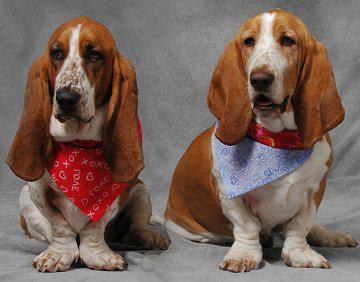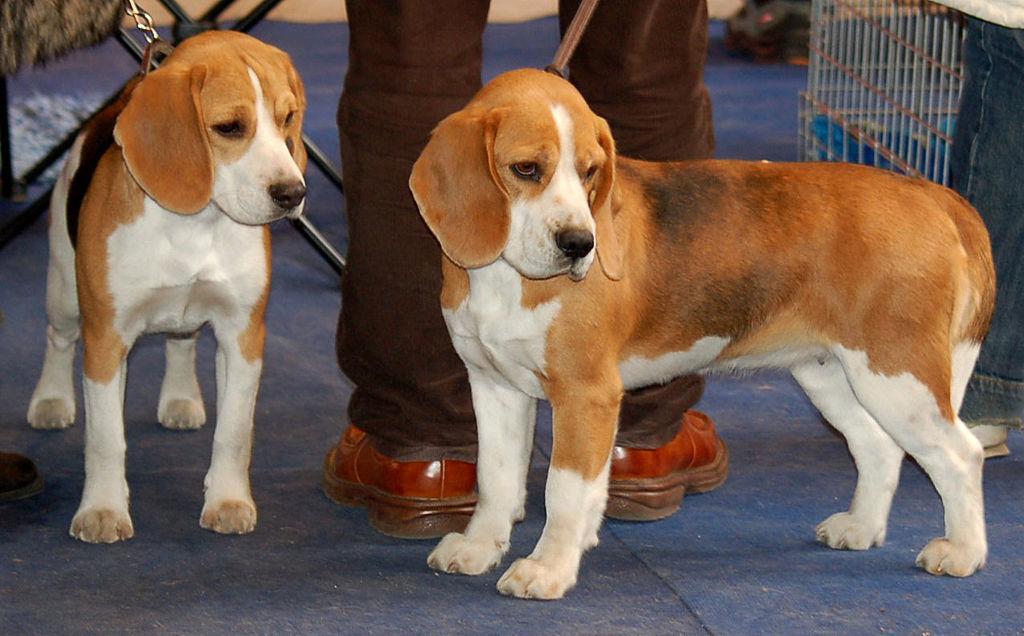The first image is the image on the left, the second image is the image on the right. Considering the images on both sides, is "There are more basset hounds in the right image than in the left." valid? Answer yes or no. No. The first image is the image on the left, the second image is the image on the right. For the images displayed, is the sentence "There is one dog in the left image" factually correct? Answer yes or no. No. 